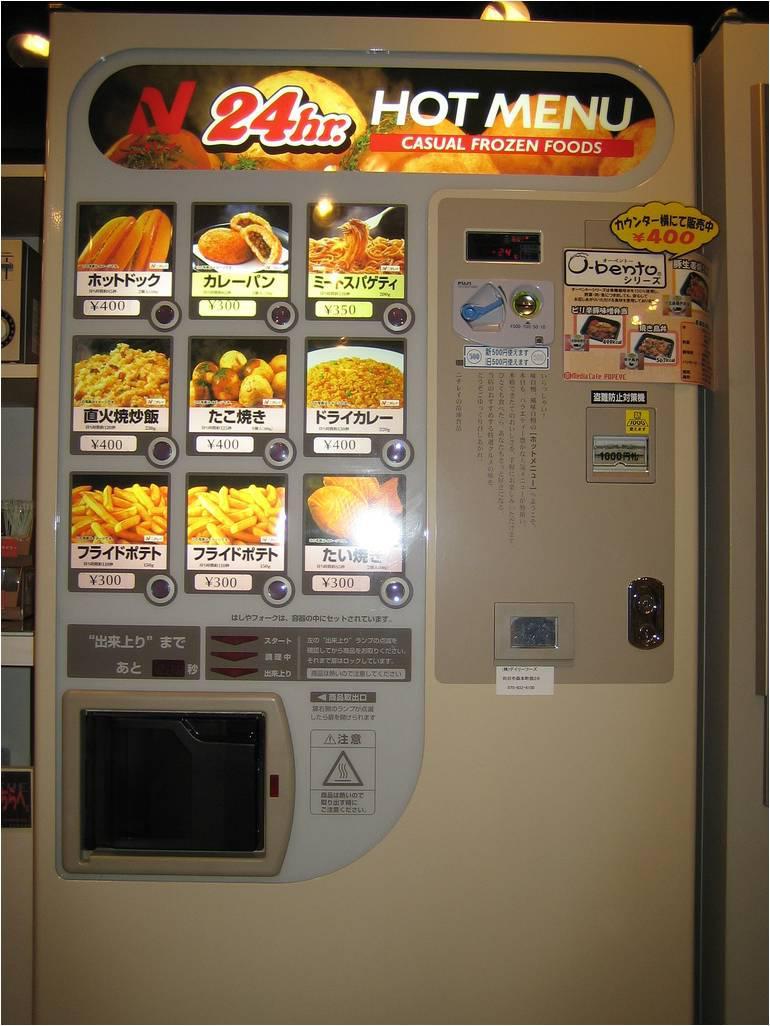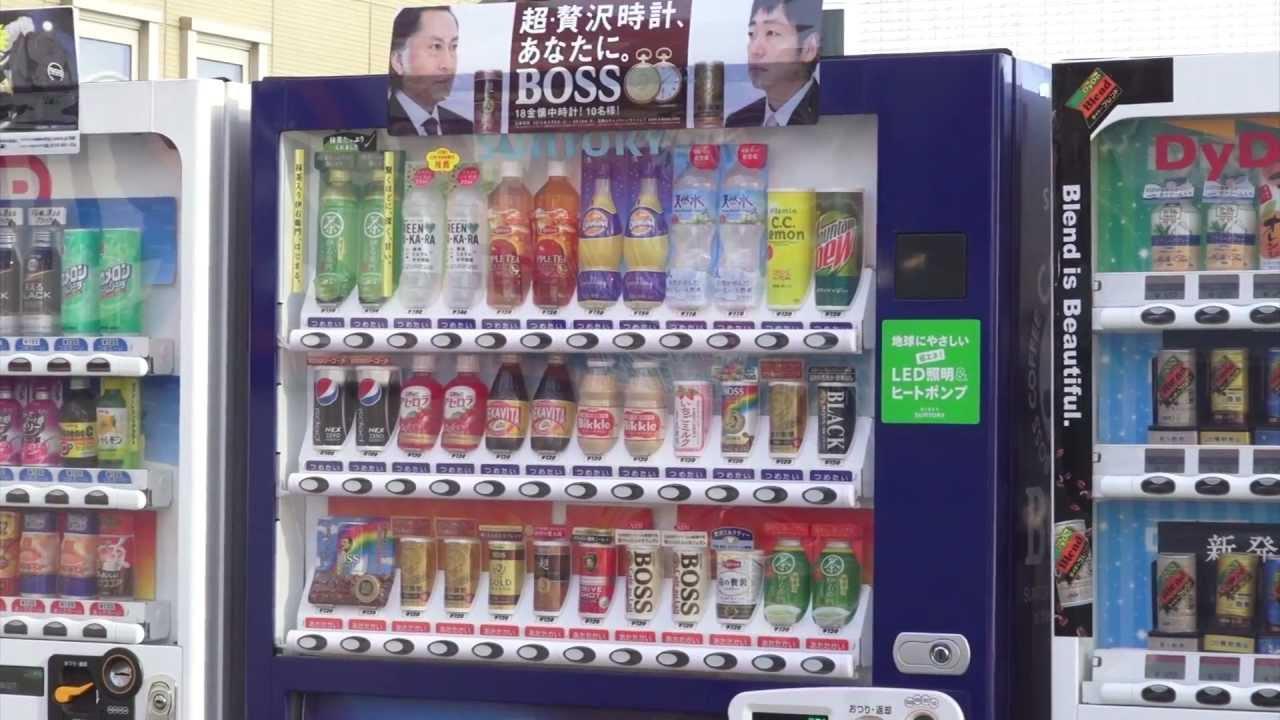The first image is the image on the left, the second image is the image on the right. Analyze the images presented: Is the assertion "The left image has a food vending machine, the right image has a beverage vending machine." valid? Answer yes or no. Yes. The first image is the image on the left, the second image is the image on the right. Evaluate the accuracy of this statement regarding the images: "One photo shows a white vending machine that clearly offers food rather than beverages.". Is it true? Answer yes or no. Yes. 